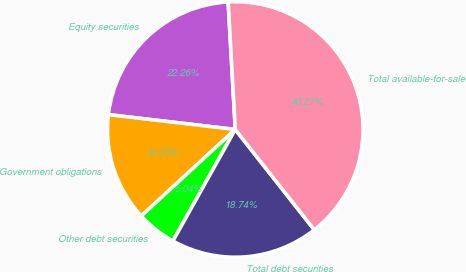<chart> <loc_0><loc_0><loc_500><loc_500><pie_chart><fcel>Equity securities<fcel>Government obligations<fcel>Other debt securities<fcel>Total debt securities<fcel>Total available-for-sale<nl><fcel>22.26%<fcel>13.7%<fcel>5.04%<fcel>18.74%<fcel>40.27%<nl></chart> 